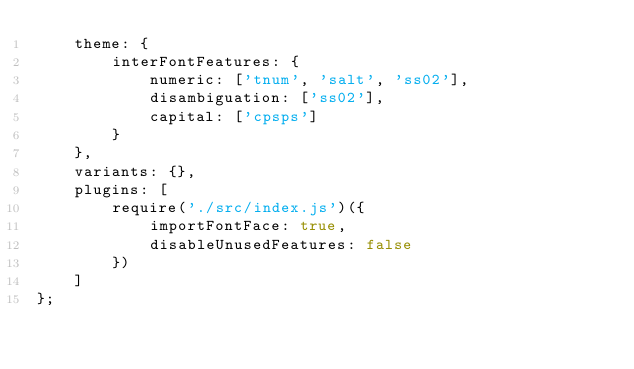Convert code to text. <code><loc_0><loc_0><loc_500><loc_500><_JavaScript_>    theme: {
        interFontFeatures: {
            numeric: ['tnum', 'salt', 'ss02'],
            disambiguation: ['ss02'],
            capital: ['cpsps']
        }
    },
    variants: {},
    plugins: [
        require('./src/index.js')({
            importFontFace: true,
            disableUnusedFeatures: false
        })
    ]
};
</code> 